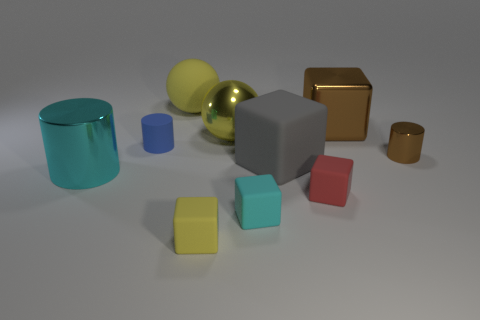Subtract all tiny red cubes. How many cubes are left? 4 Subtract all brown blocks. How many blocks are left? 4 Subtract all purple cubes. Subtract all red balls. How many cubes are left? 5 Subtract all cylinders. How many objects are left? 7 Add 5 small blue objects. How many small blue objects exist? 6 Subtract 0 green cubes. How many objects are left? 10 Subtract all blue rubber cylinders. Subtract all small red things. How many objects are left? 8 Add 4 big yellow balls. How many big yellow balls are left? 6 